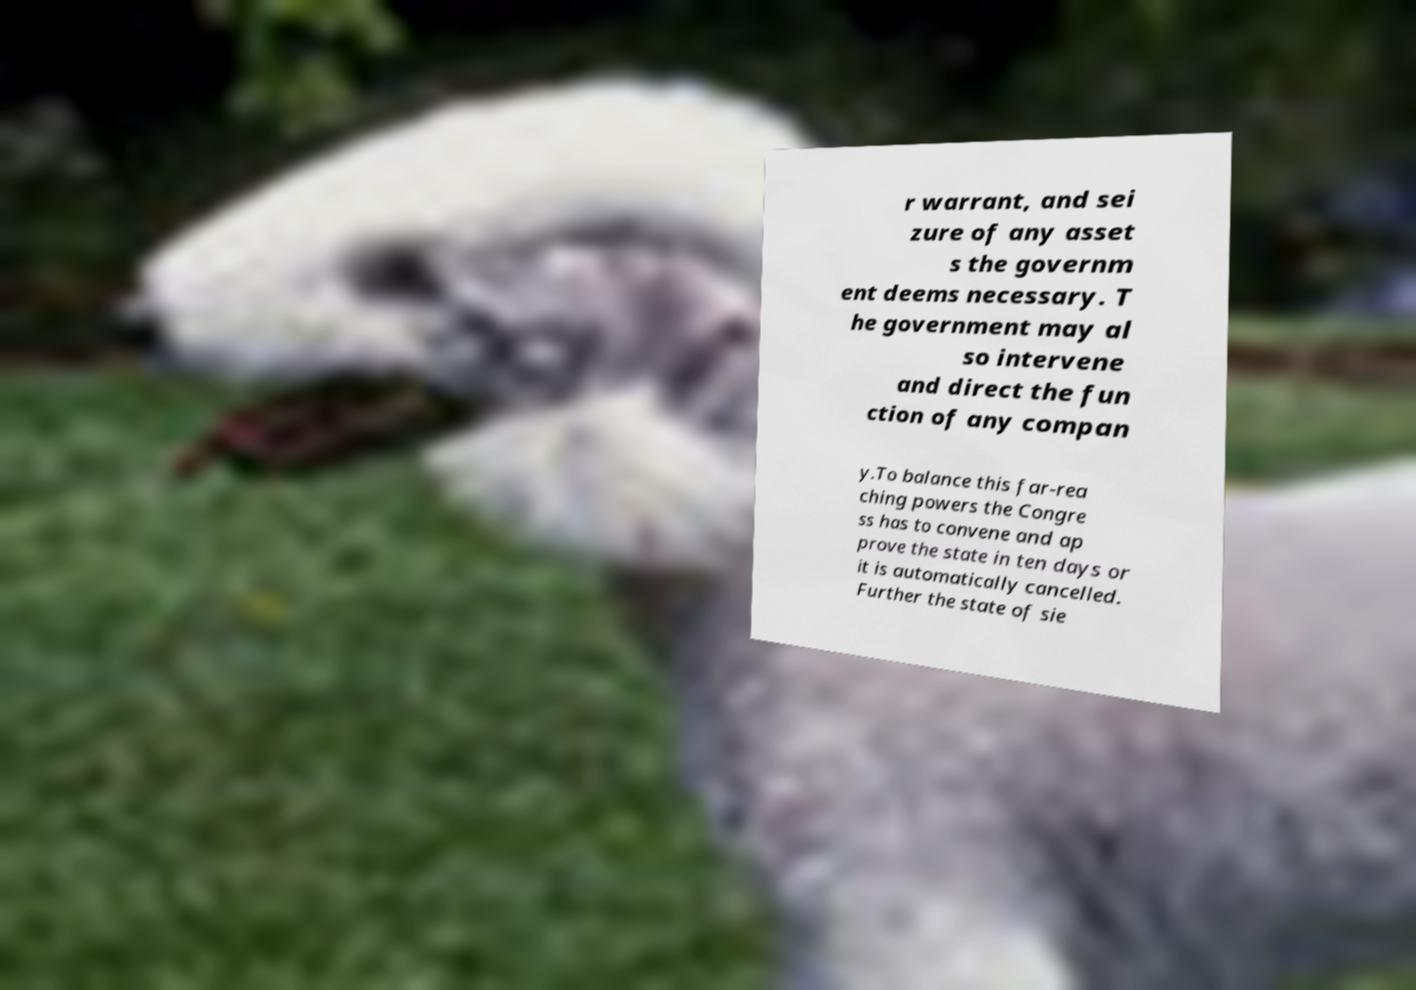Please read and relay the text visible in this image. What does it say? r warrant, and sei zure of any asset s the governm ent deems necessary. T he government may al so intervene and direct the fun ction of any compan y.To balance this far-rea ching powers the Congre ss has to convene and ap prove the state in ten days or it is automatically cancelled. Further the state of sie 